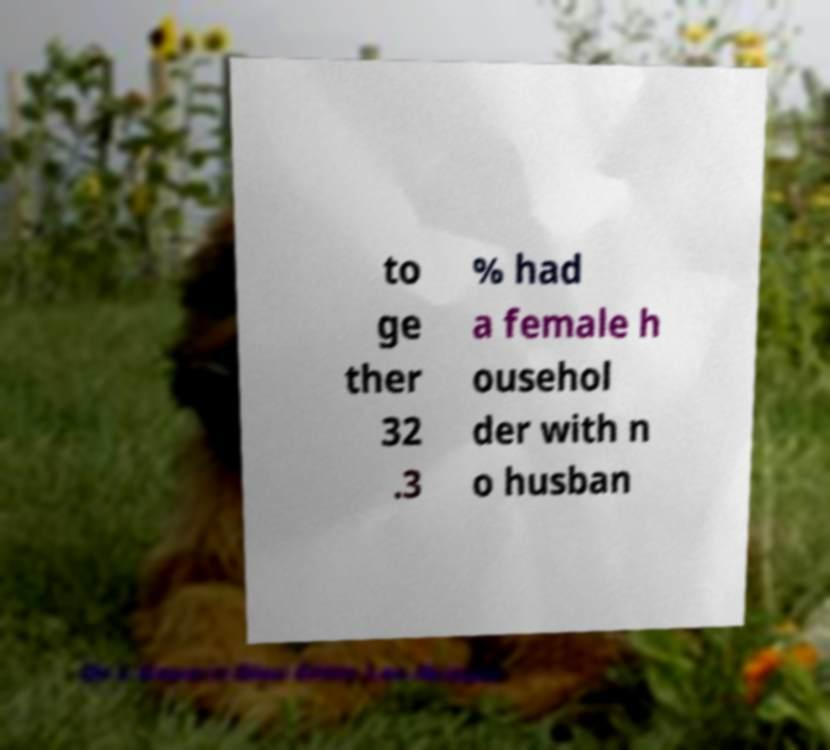Can you read and provide the text displayed in the image?This photo seems to have some interesting text. Can you extract and type it out for me? to ge ther 32 .3 % had a female h ousehol der with n o husban 